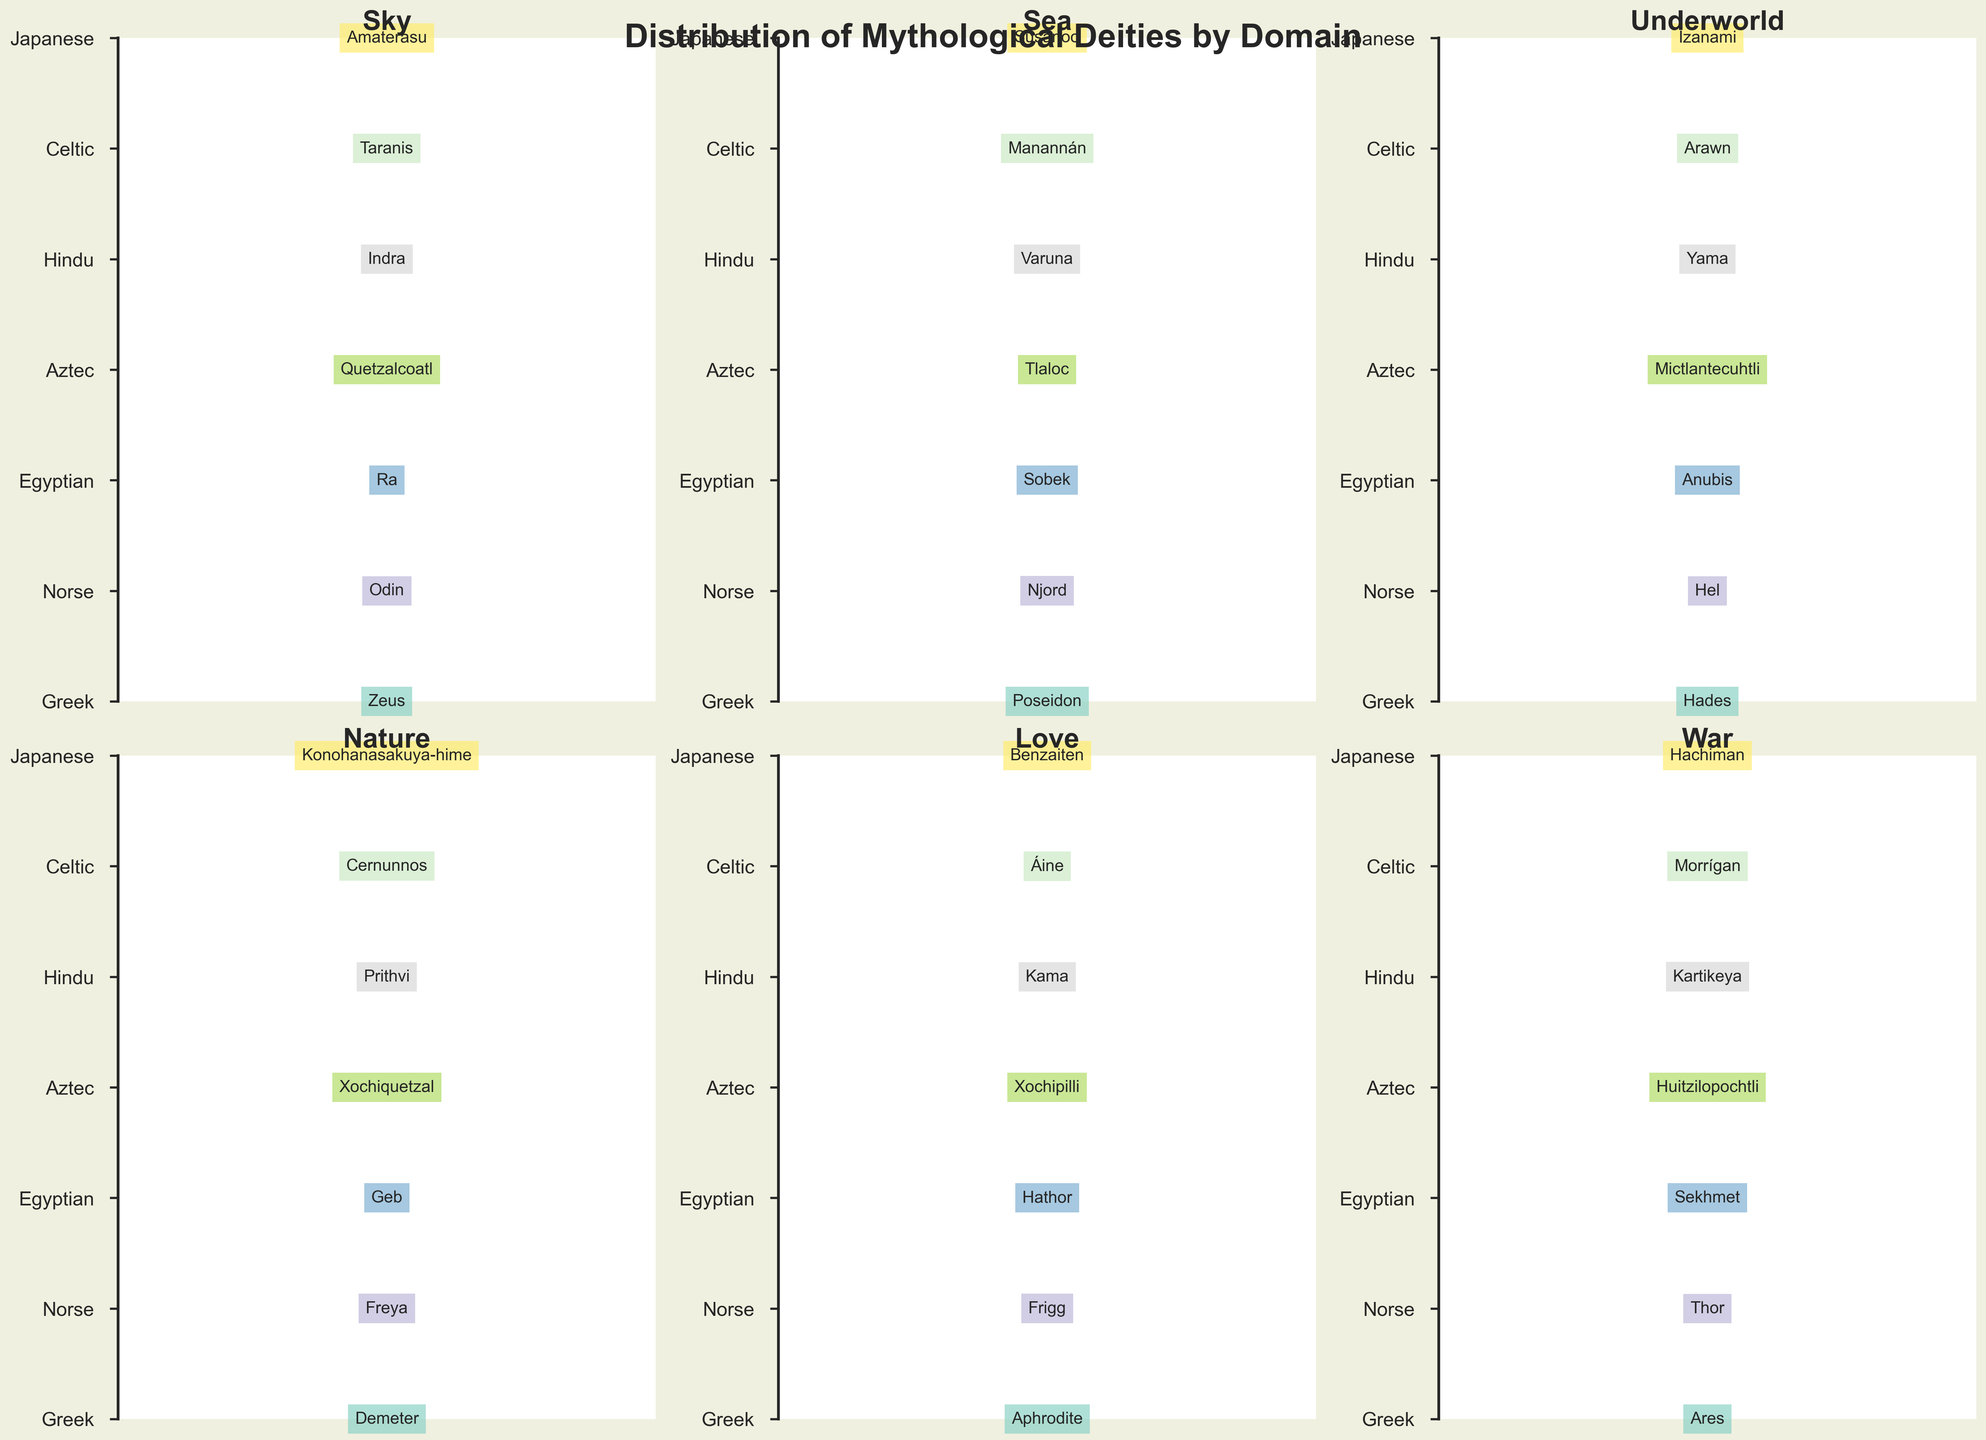Which pantheon has the deity Huitzilopochtli associated with 'War'? Look for 'War' section and find Huitzilopochtli. Huitzilopochtli is listed under the 'War' section in the Aztec pantheon.
Answer: Aztec How many deities are associated with the 'Sky' domain? Count the number of deities listed under the 'Sky' domain. There is one deity listed for each pantheon: Zeus, Odin, Ra, Quetzalcoatl, Indra, Taranis, and Amaterasu. So, there are 7 deities in total.
Answer: 7 Which deities are associated with the 'Underworld' domain for the Greek and Norse pantheons? Look under the 'Underworld' section for both Greek and Norse pantheons. For the Greek pantheon, Hades is listed, and for the Norse pantheon, Hel is listed in the 'Underworld' section.
Answer: Hades (Greek), Hel (Norse) Which domain has the deity with the name with the greatest number of characters? Examine the length of deity names in each domain. The longest name appears to be Mictlantecuhtli under the 'Underworld' domain with 14 characters.
Answer: Underworld How many different domains does each pantheon have associated deities in? Each pantheon has one deity per each domain: Sky, Sea, Underworld, Nature, Love, and War. Count the unique domains for any pantheon. All pantheons are represented in all six domains in the data provided.
Answer: 6 domains per pantheon Compare the deities for 'Nature' across the Egyptian and Hindu pantheons. Which names are given? Look at the 'Nature' section for both pantheons. 'Nature' deities listed are Geb for the Egyptian pantheon and Prithvi for the Hindu pantheon.
Answer: Geb (Egyptian), Prithvi (Hindu) Which pantheon has the deity Frigg, and with which domain is Frigg associated? Look for the deity Frigg in the plot. Frigg is listed under the 'Love' domain in the Norse pantheon.
Answer: Norse, Love What is the most common color used in the plot, and why is it significant? Observe colors used to represent each deity. The question requires counting color appearances. Most likely, there's one unique color per row, making it the same occurrence for each pantheon, thus there's no most common color in this balanced approach.
Answer: No single most common color Which deity is associated with 'Sea' in the Japanese pantheon? Under the 'Sea' section, locate the deity for the Japanese pantheon. Susanoo is listed as the 'Sea' deity for the Japanese pantheon.
Answer: Susanoo Compare the deities in the 'War' domain for Celtic and Hindu pantheons. Look at the 'War' section for both Celtic and Hindu pantheons. For the Hindu pantheon, Kartikeya is listed, and for the Celtic pantheon, Morrígan is listed.
Answer: Kartikeya (Hindu), Morrígan (Celtic) 